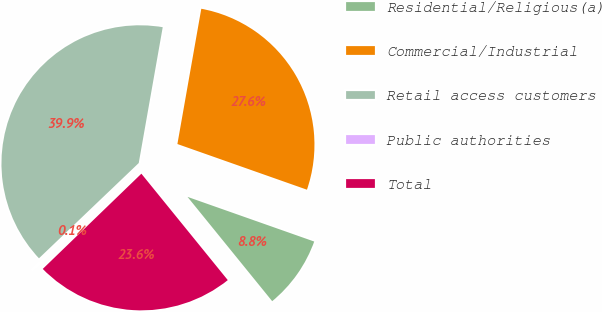Convert chart to OTSL. <chart><loc_0><loc_0><loc_500><loc_500><pie_chart><fcel>Residential/Religious(a)<fcel>Commercial/Industrial<fcel>Retail access customers<fcel>Public authorities<fcel>Total<nl><fcel>8.75%<fcel>27.61%<fcel>39.91%<fcel>0.09%<fcel>23.63%<nl></chart> 